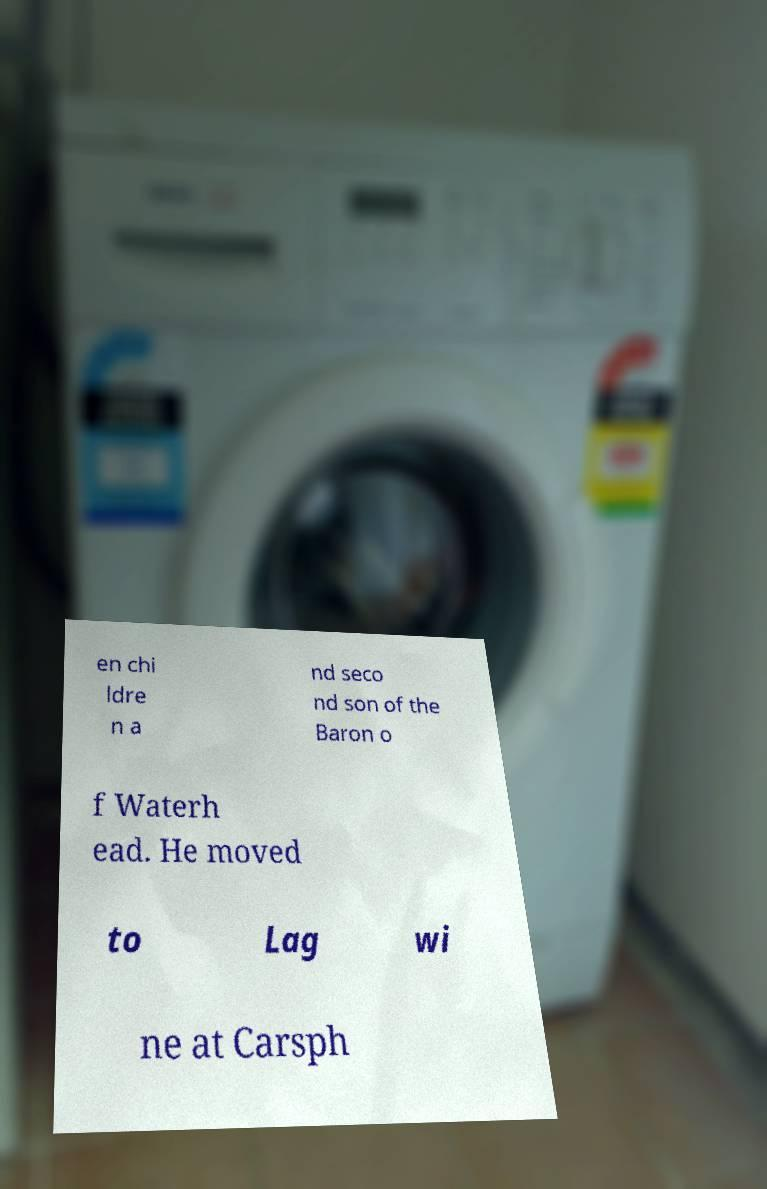For documentation purposes, I need the text within this image transcribed. Could you provide that? en chi ldre n a nd seco nd son of the Baron o f Waterh ead. He moved to Lag wi ne at Carsph 